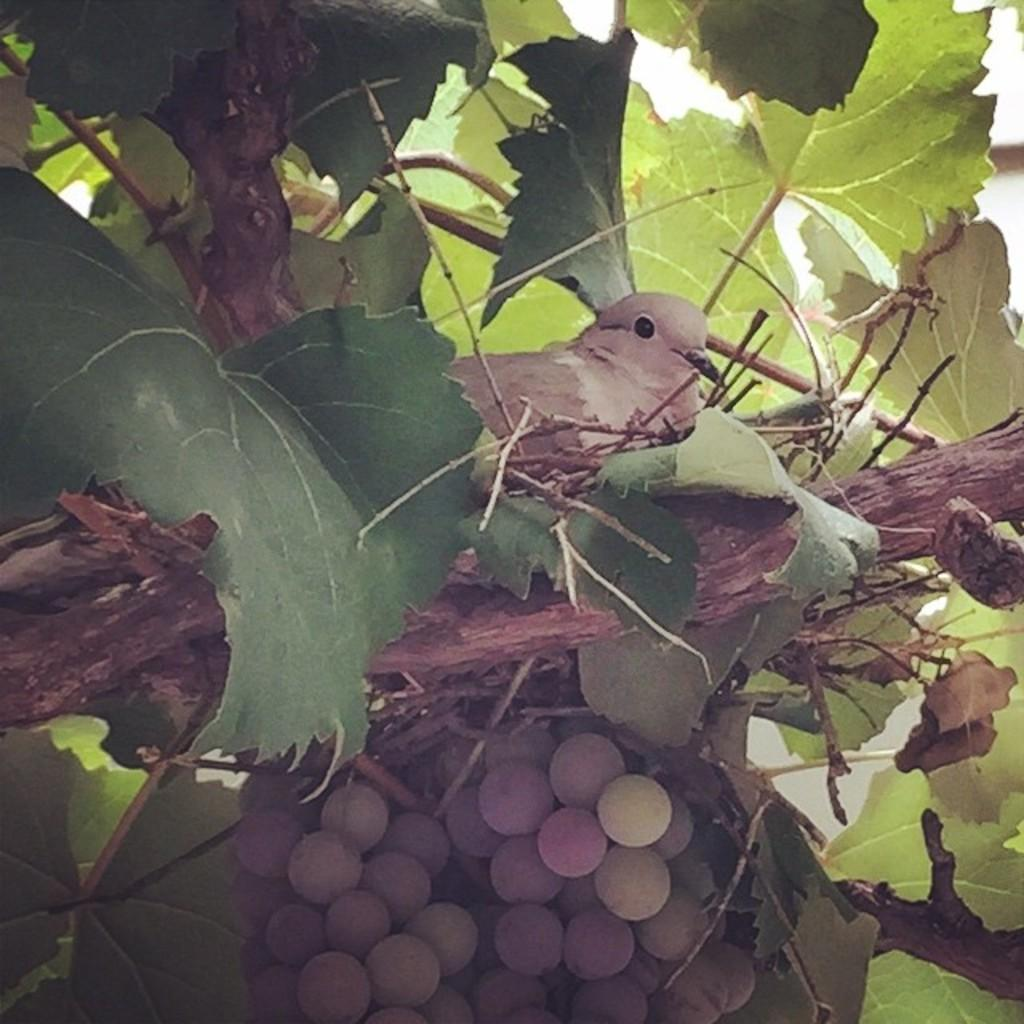What type of animal can be seen in the nest in the image? There is a bird in the nest in the image. What type of food is visible in the image? There are fruits in the image. What type of plant is present in the image? There is a tree in the image. What type of wax is used to make the bird's collar in the image? There is no bird's collar present in the image, and therefore no wax is used. How does the bird run around in the image? The bird does not run around in the image; it is perched in the nest. 